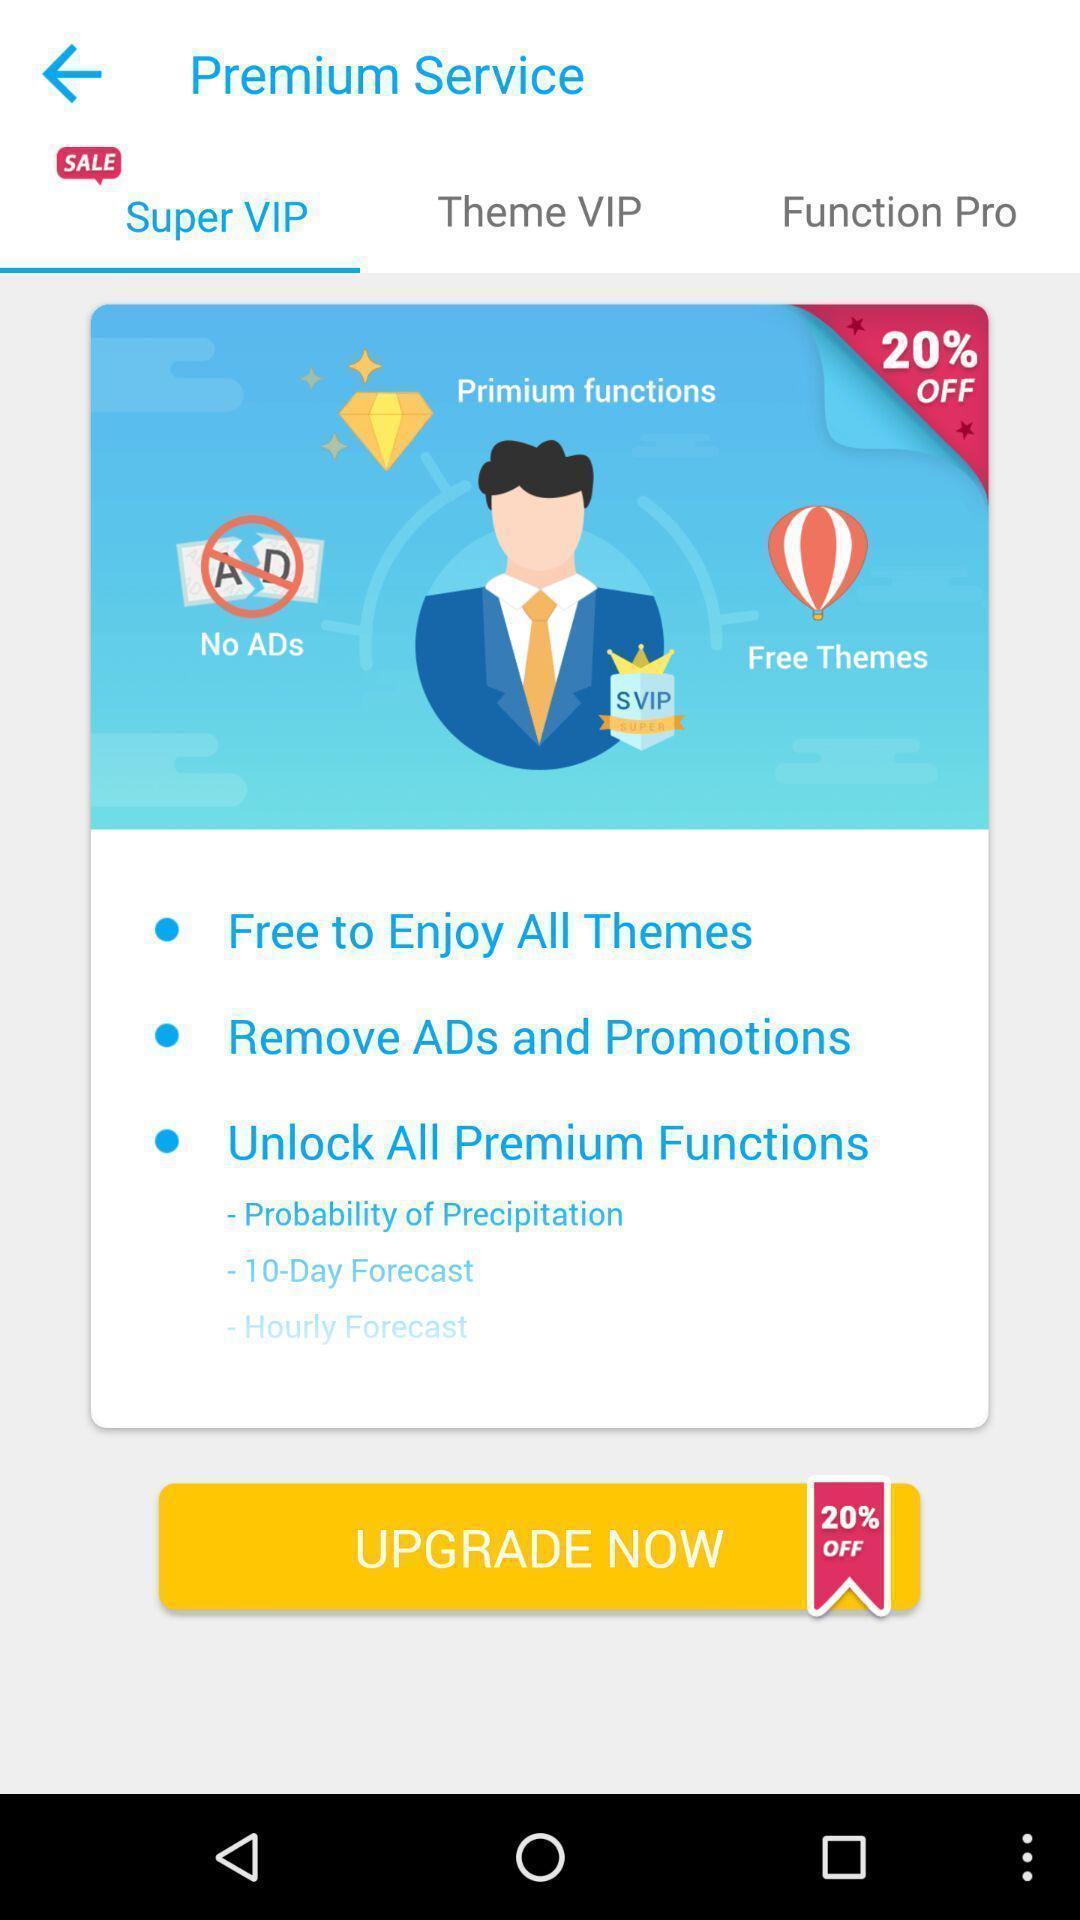Tell me what you see in this picture. Pop up window to upgrade to premium. 